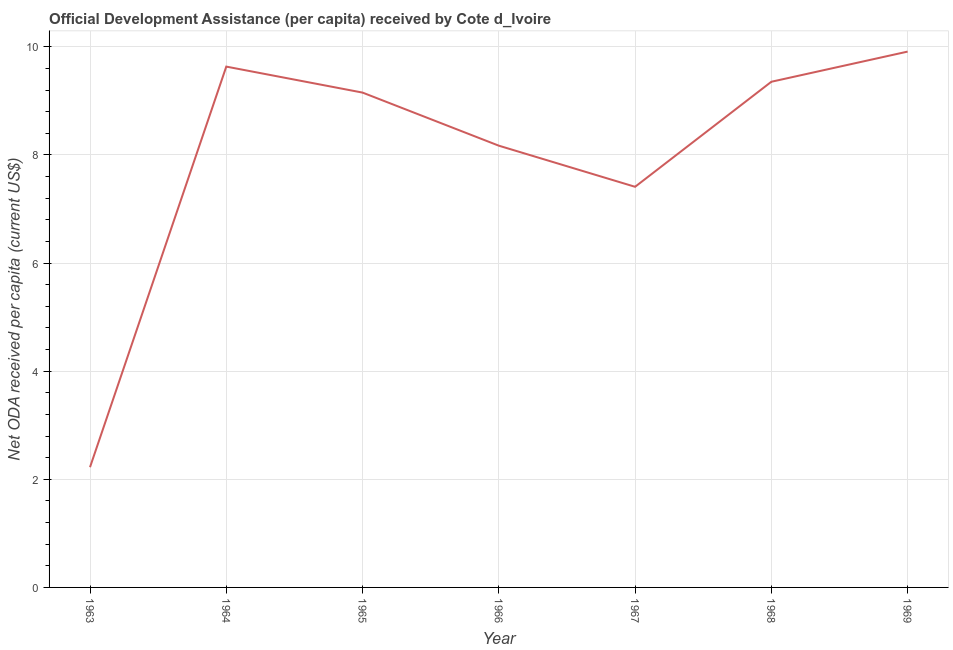What is the net oda received per capita in 1965?
Make the answer very short. 9.15. Across all years, what is the maximum net oda received per capita?
Provide a succinct answer. 9.91. Across all years, what is the minimum net oda received per capita?
Your answer should be very brief. 2.22. In which year was the net oda received per capita maximum?
Offer a terse response. 1969. What is the sum of the net oda received per capita?
Provide a succinct answer. 55.85. What is the difference between the net oda received per capita in 1966 and 1968?
Your response must be concise. -1.18. What is the average net oda received per capita per year?
Your answer should be very brief. 7.98. What is the median net oda received per capita?
Keep it short and to the point. 9.15. In how many years, is the net oda received per capita greater than 4.4 US$?
Your answer should be compact. 6. Do a majority of the years between 1967 and 1964 (inclusive) have net oda received per capita greater than 1.2000000000000002 US$?
Ensure brevity in your answer.  Yes. What is the ratio of the net oda received per capita in 1963 to that in 1964?
Make the answer very short. 0.23. Is the net oda received per capita in 1963 less than that in 1967?
Your response must be concise. Yes. Is the difference between the net oda received per capita in 1963 and 1969 greater than the difference between any two years?
Make the answer very short. Yes. What is the difference between the highest and the second highest net oda received per capita?
Provide a succinct answer. 0.28. What is the difference between the highest and the lowest net oda received per capita?
Provide a short and direct response. 7.69. Does the net oda received per capita monotonically increase over the years?
Give a very brief answer. No. How many years are there in the graph?
Give a very brief answer. 7. Does the graph contain any zero values?
Offer a terse response. No. What is the title of the graph?
Keep it short and to the point. Official Development Assistance (per capita) received by Cote d_Ivoire. What is the label or title of the X-axis?
Ensure brevity in your answer.  Year. What is the label or title of the Y-axis?
Offer a very short reply. Net ODA received per capita (current US$). What is the Net ODA received per capita (current US$) of 1963?
Make the answer very short. 2.22. What is the Net ODA received per capita (current US$) of 1964?
Provide a succinct answer. 9.63. What is the Net ODA received per capita (current US$) in 1965?
Provide a short and direct response. 9.15. What is the Net ODA received per capita (current US$) of 1966?
Offer a very short reply. 8.17. What is the Net ODA received per capita (current US$) of 1967?
Keep it short and to the point. 7.41. What is the Net ODA received per capita (current US$) of 1968?
Your answer should be compact. 9.35. What is the Net ODA received per capita (current US$) of 1969?
Your answer should be very brief. 9.91. What is the difference between the Net ODA received per capita (current US$) in 1963 and 1964?
Your answer should be compact. -7.41. What is the difference between the Net ODA received per capita (current US$) in 1963 and 1965?
Keep it short and to the point. -6.93. What is the difference between the Net ODA received per capita (current US$) in 1963 and 1966?
Ensure brevity in your answer.  -5.95. What is the difference between the Net ODA received per capita (current US$) in 1963 and 1967?
Give a very brief answer. -5.19. What is the difference between the Net ODA received per capita (current US$) in 1963 and 1968?
Keep it short and to the point. -7.13. What is the difference between the Net ODA received per capita (current US$) in 1963 and 1969?
Keep it short and to the point. -7.69. What is the difference between the Net ODA received per capita (current US$) in 1964 and 1965?
Provide a short and direct response. 0.48. What is the difference between the Net ODA received per capita (current US$) in 1964 and 1966?
Provide a short and direct response. 1.46. What is the difference between the Net ODA received per capita (current US$) in 1964 and 1967?
Make the answer very short. 2.22. What is the difference between the Net ODA received per capita (current US$) in 1964 and 1968?
Keep it short and to the point. 0.28. What is the difference between the Net ODA received per capita (current US$) in 1964 and 1969?
Your answer should be compact. -0.28. What is the difference between the Net ODA received per capita (current US$) in 1965 and 1966?
Give a very brief answer. 0.98. What is the difference between the Net ODA received per capita (current US$) in 1965 and 1967?
Your answer should be very brief. 1.74. What is the difference between the Net ODA received per capita (current US$) in 1965 and 1968?
Your answer should be very brief. -0.2. What is the difference between the Net ODA received per capita (current US$) in 1965 and 1969?
Your answer should be compact. -0.76. What is the difference between the Net ODA received per capita (current US$) in 1966 and 1967?
Your response must be concise. 0.76. What is the difference between the Net ODA received per capita (current US$) in 1966 and 1968?
Ensure brevity in your answer.  -1.18. What is the difference between the Net ODA received per capita (current US$) in 1966 and 1969?
Offer a terse response. -1.74. What is the difference between the Net ODA received per capita (current US$) in 1967 and 1968?
Provide a short and direct response. -1.94. What is the difference between the Net ODA received per capita (current US$) in 1967 and 1969?
Make the answer very short. -2.5. What is the difference between the Net ODA received per capita (current US$) in 1968 and 1969?
Your answer should be compact. -0.56. What is the ratio of the Net ODA received per capita (current US$) in 1963 to that in 1964?
Offer a very short reply. 0.23. What is the ratio of the Net ODA received per capita (current US$) in 1963 to that in 1965?
Provide a succinct answer. 0.24. What is the ratio of the Net ODA received per capita (current US$) in 1963 to that in 1966?
Make the answer very short. 0.27. What is the ratio of the Net ODA received per capita (current US$) in 1963 to that in 1968?
Ensure brevity in your answer.  0.24. What is the ratio of the Net ODA received per capita (current US$) in 1963 to that in 1969?
Your answer should be compact. 0.22. What is the ratio of the Net ODA received per capita (current US$) in 1964 to that in 1965?
Provide a succinct answer. 1.05. What is the ratio of the Net ODA received per capita (current US$) in 1964 to that in 1966?
Provide a succinct answer. 1.18. What is the ratio of the Net ODA received per capita (current US$) in 1964 to that in 1968?
Provide a short and direct response. 1.03. What is the ratio of the Net ODA received per capita (current US$) in 1965 to that in 1966?
Give a very brief answer. 1.12. What is the ratio of the Net ODA received per capita (current US$) in 1965 to that in 1967?
Give a very brief answer. 1.24. What is the ratio of the Net ODA received per capita (current US$) in 1965 to that in 1969?
Offer a terse response. 0.92. What is the ratio of the Net ODA received per capita (current US$) in 1966 to that in 1967?
Provide a short and direct response. 1.1. What is the ratio of the Net ODA received per capita (current US$) in 1966 to that in 1968?
Provide a short and direct response. 0.87. What is the ratio of the Net ODA received per capita (current US$) in 1966 to that in 1969?
Keep it short and to the point. 0.82. What is the ratio of the Net ODA received per capita (current US$) in 1967 to that in 1968?
Give a very brief answer. 0.79. What is the ratio of the Net ODA received per capita (current US$) in 1967 to that in 1969?
Keep it short and to the point. 0.75. What is the ratio of the Net ODA received per capita (current US$) in 1968 to that in 1969?
Provide a succinct answer. 0.94. 